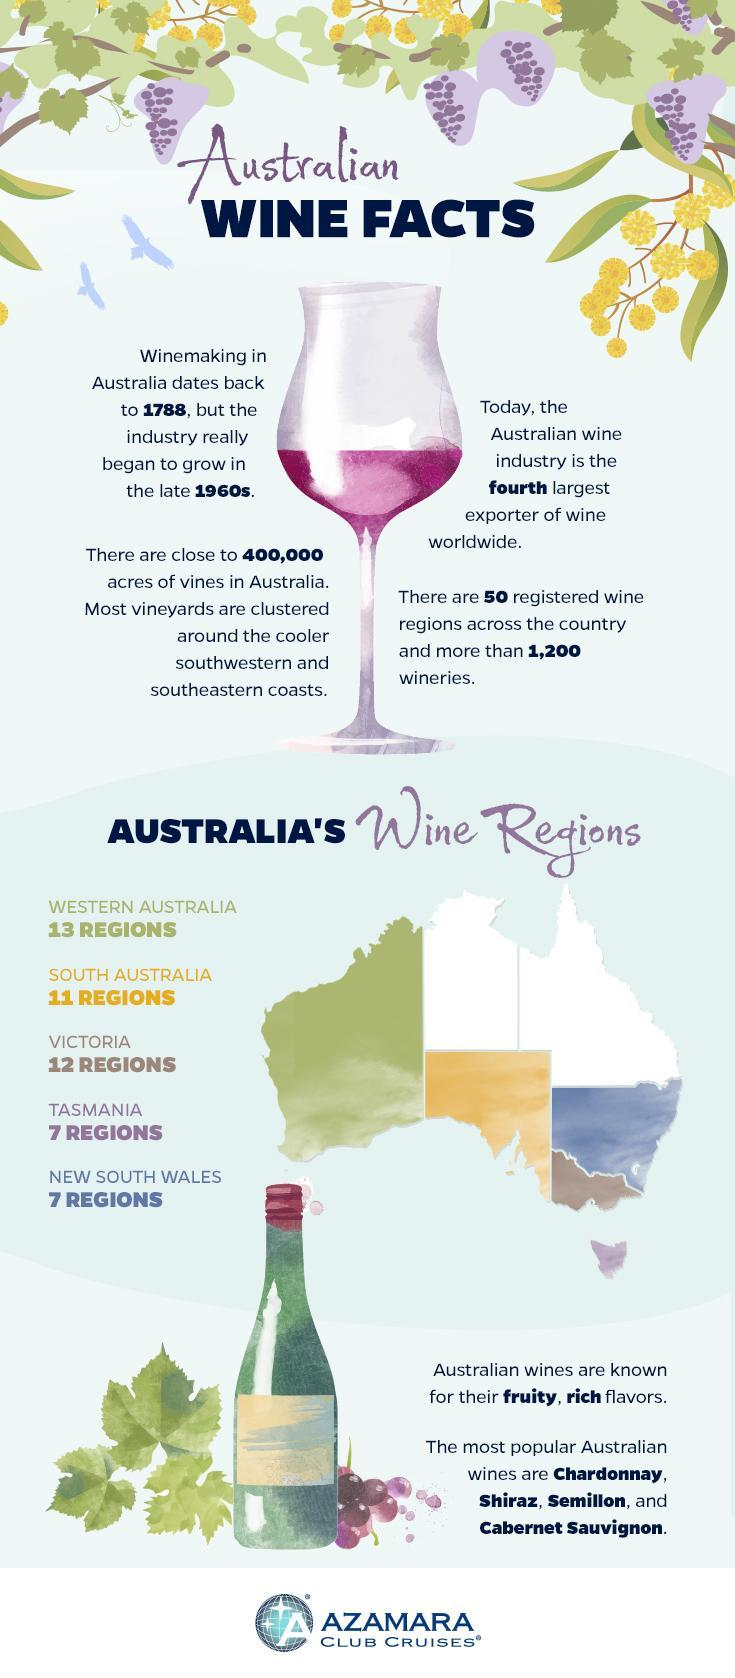Which color is used to fill the largest section in the map blue, yellow, or green ?
Answer the question with a short phrase. green Which wine region appears as an island towards the south east part of the map ? Tasmania Which color represents South Australia on the map green, yellow or blue? yellow The blue color on the map represents which wine region Tasmania,  Western Australia or New South Wales ? New South Wales 